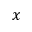Convert formula to latex. <formula><loc_0><loc_0><loc_500><loc_500>x</formula> 